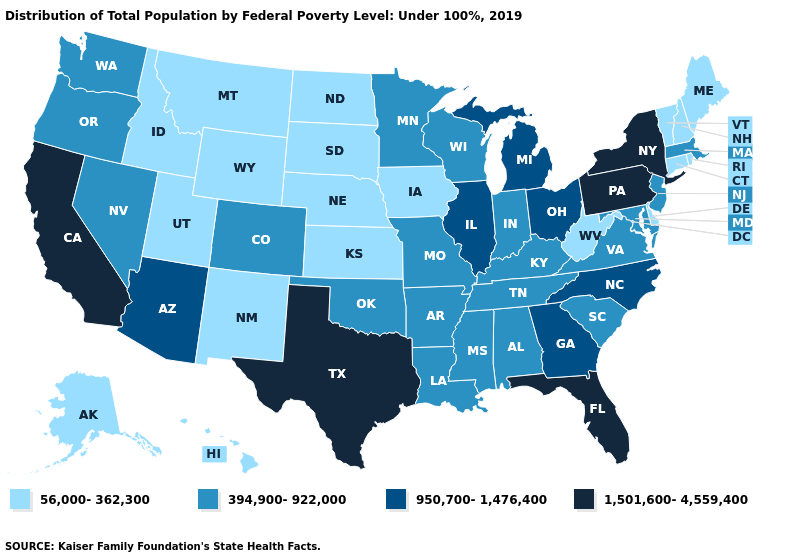Does Tennessee have the same value as Kansas?
Keep it brief. No. Is the legend a continuous bar?
Write a very short answer. No. What is the value of New Jersey?
Write a very short answer. 394,900-922,000. What is the highest value in states that border Oregon?
Give a very brief answer. 1,501,600-4,559,400. Does the map have missing data?
Concise answer only. No. What is the value of Missouri?
Give a very brief answer. 394,900-922,000. What is the value of Oklahoma?
Give a very brief answer. 394,900-922,000. Name the states that have a value in the range 1,501,600-4,559,400?
Short answer required. California, Florida, New York, Pennsylvania, Texas. How many symbols are there in the legend?
Quick response, please. 4. Which states have the highest value in the USA?
Short answer required. California, Florida, New York, Pennsylvania, Texas. Is the legend a continuous bar?
Write a very short answer. No. What is the value of Wyoming?
Quick response, please. 56,000-362,300. What is the value of Georgia?
Concise answer only. 950,700-1,476,400. What is the lowest value in the MidWest?
Write a very short answer. 56,000-362,300. Name the states that have a value in the range 56,000-362,300?
Keep it brief. Alaska, Connecticut, Delaware, Hawaii, Idaho, Iowa, Kansas, Maine, Montana, Nebraska, New Hampshire, New Mexico, North Dakota, Rhode Island, South Dakota, Utah, Vermont, West Virginia, Wyoming. 